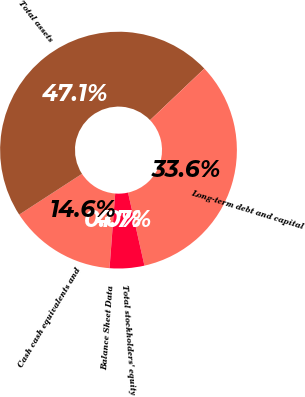<chart> <loc_0><loc_0><loc_500><loc_500><pie_chart><fcel>Balance Sheet Data<fcel>Cash cash equivalents and<fcel>Total assets<fcel>Long-term debt and capital<fcel>Total stockholders' equity<nl><fcel>0.01%<fcel>14.62%<fcel>47.08%<fcel>33.58%<fcel>4.72%<nl></chart> 